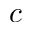<formula> <loc_0><loc_0><loc_500><loc_500>c</formula> 